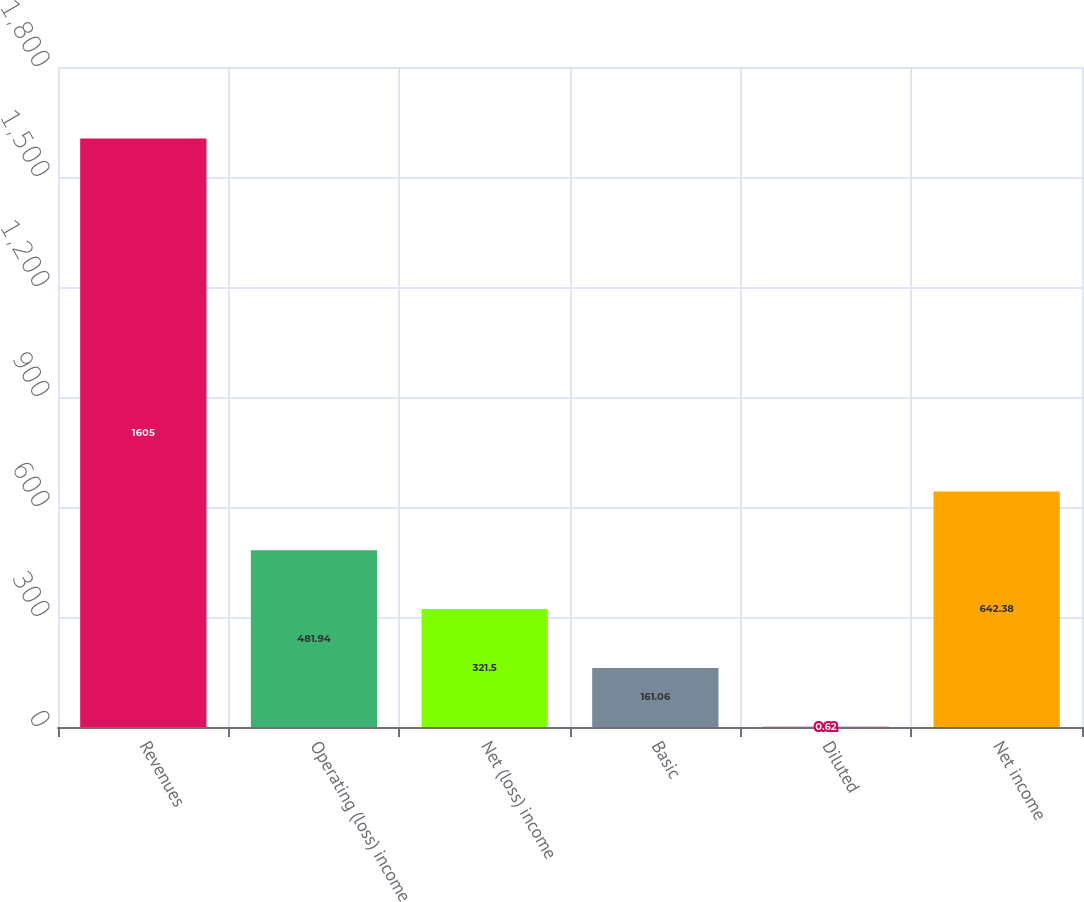Convert chart to OTSL. <chart><loc_0><loc_0><loc_500><loc_500><bar_chart><fcel>Revenues<fcel>Operating (loss) income<fcel>Net (loss) income<fcel>Basic<fcel>Diluted<fcel>Net income<nl><fcel>1605<fcel>481.94<fcel>321.5<fcel>161.06<fcel>0.62<fcel>642.38<nl></chart> 